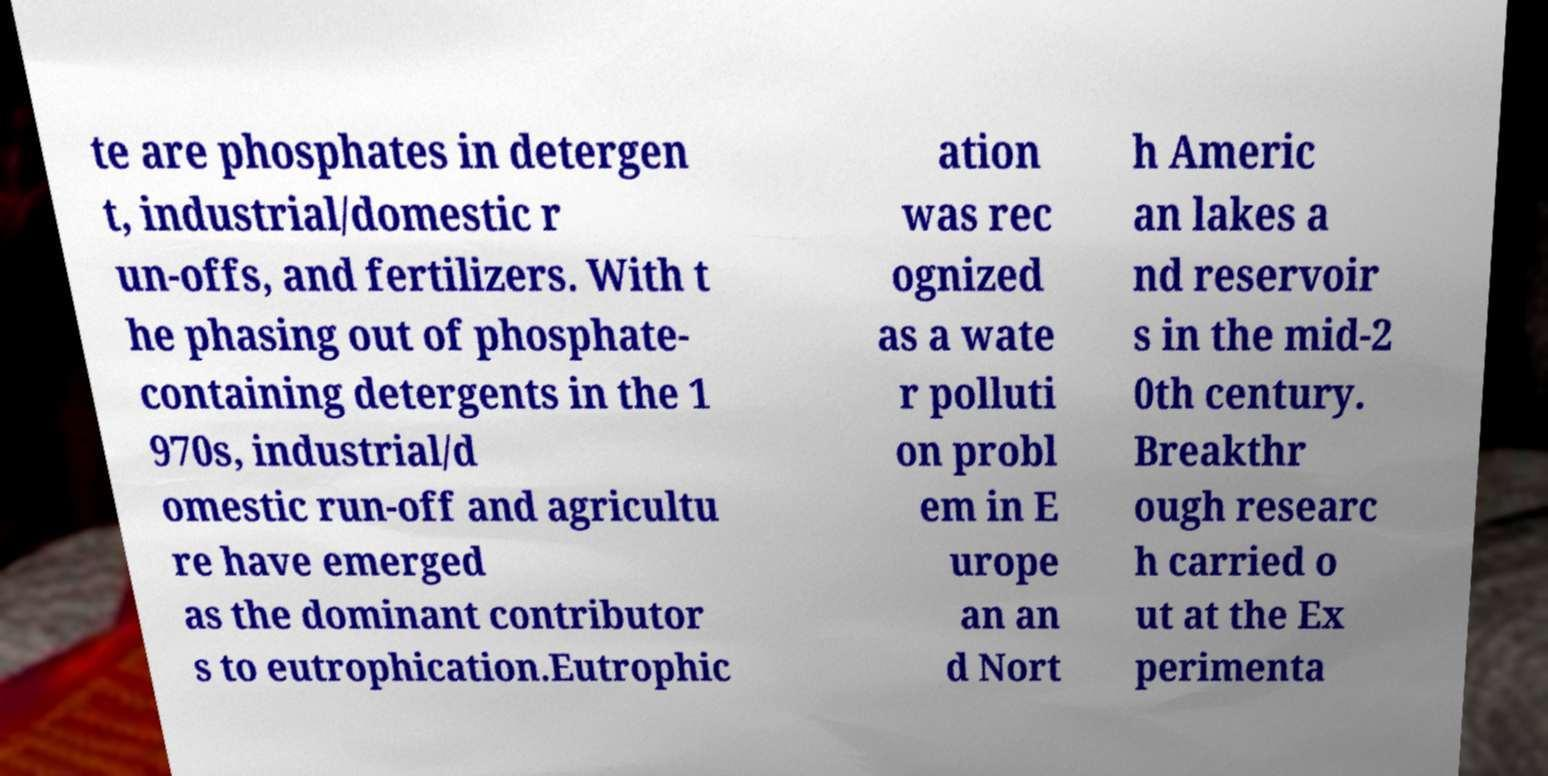What messages or text are displayed in this image? I need them in a readable, typed format. te are phosphates in detergen t, industrial/domestic r un-offs, and fertilizers. With t he phasing out of phosphate- containing detergents in the 1 970s, industrial/d omestic run-off and agricultu re have emerged as the dominant contributor s to eutrophication.Eutrophic ation was rec ognized as a wate r polluti on probl em in E urope an an d Nort h Americ an lakes a nd reservoir s in the mid-2 0th century. Breakthr ough researc h carried o ut at the Ex perimenta 